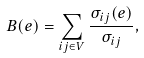Convert formula to latex. <formula><loc_0><loc_0><loc_500><loc_500>B ( e ) = \sum _ { i j \in V } \frac { \sigma _ { i j } ( e ) } { \sigma _ { i j } } ,</formula> 